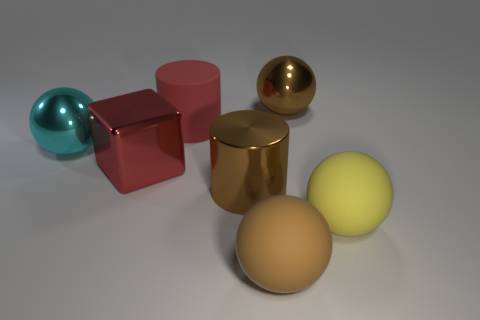Subtract 1 spheres. How many spheres are left? 3 Add 2 small cyan metal balls. How many objects exist? 9 Subtract all balls. How many objects are left? 3 Add 6 big metal cylinders. How many big metal cylinders are left? 7 Add 2 big metal cubes. How many big metal cubes exist? 3 Subtract 0 purple blocks. How many objects are left? 7 Subtract all large metallic cubes. Subtract all small green matte spheres. How many objects are left? 6 